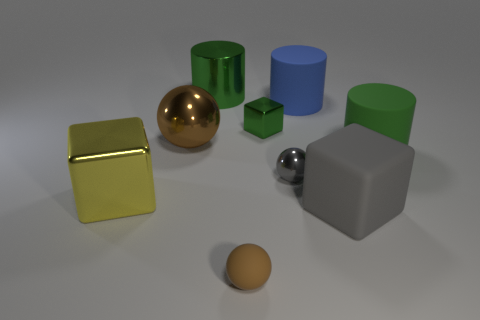Are there more shiny cubes right of the tiny brown rubber object than brown things that are to the right of the tiny shiny ball?
Give a very brief answer. Yes. There is a blue thing that is to the left of the green rubber cylinder; what is its material?
Offer a terse response. Rubber. Do the blue rubber object and the large green thing that is right of the brown matte object have the same shape?
Make the answer very short. Yes. What number of small green blocks are left of the large green cylinder that is left of the big green object to the right of the tiny cube?
Give a very brief answer. 0. What color is the other matte object that is the same shape as the blue matte thing?
Keep it short and to the point. Green. Is there any other thing that has the same shape as the blue object?
Make the answer very short. Yes. What number of cubes are either big brown shiny objects or gray objects?
Provide a short and direct response. 1. What is the shape of the big gray rubber thing?
Make the answer very short. Cube. Are there any metallic spheres on the right side of the big metallic cube?
Give a very brief answer. Yes. Does the large blue cylinder have the same material as the large green thing in front of the large blue cylinder?
Give a very brief answer. Yes. 